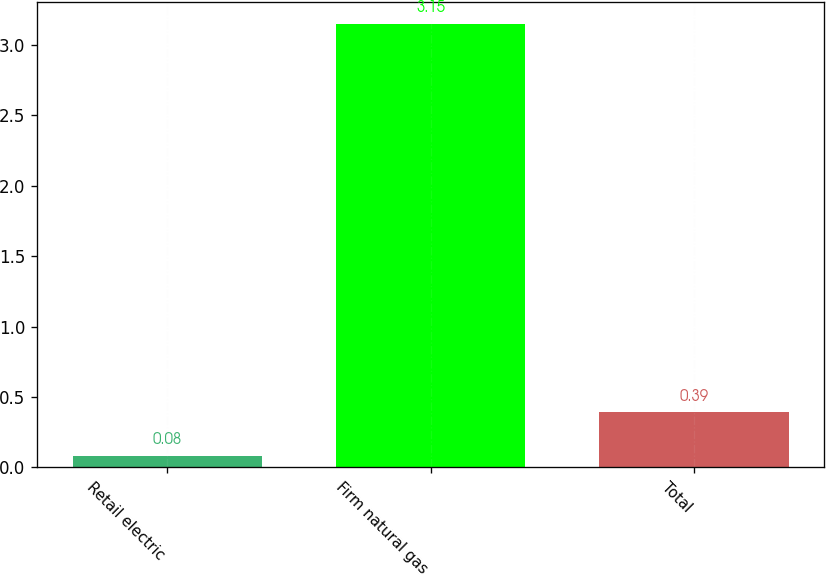<chart> <loc_0><loc_0><loc_500><loc_500><bar_chart><fcel>Retail electric<fcel>Firm natural gas<fcel>Total<nl><fcel>0.08<fcel>3.15<fcel>0.39<nl></chart> 